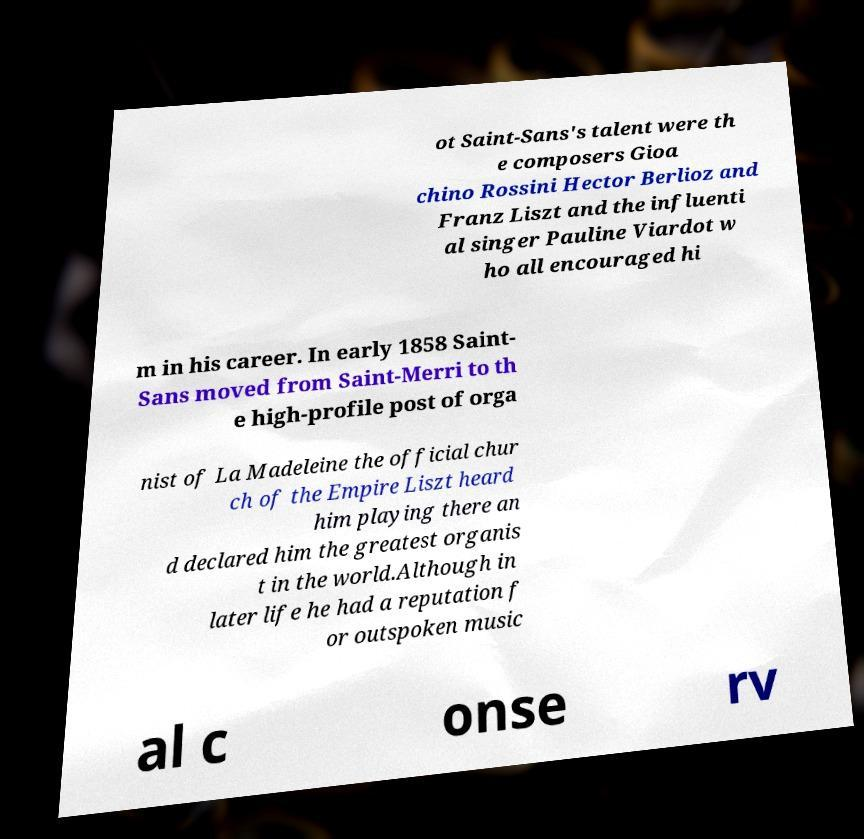What messages or text are displayed in this image? I need them in a readable, typed format. ot Saint-Sans's talent were th e composers Gioa chino Rossini Hector Berlioz and Franz Liszt and the influenti al singer Pauline Viardot w ho all encouraged hi m in his career. In early 1858 Saint- Sans moved from Saint-Merri to th e high-profile post of orga nist of La Madeleine the official chur ch of the Empire Liszt heard him playing there an d declared him the greatest organis t in the world.Although in later life he had a reputation f or outspoken music al c onse rv 